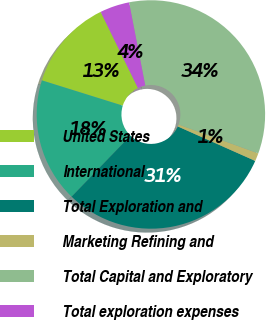<chart> <loc_0><loc_0><loc_500><loc_500><pie_chart><fcel>United States<fcel>International<fcel>Total Exploration and<fcel>Marketing Refining and<fcel>Total Capital and Exploratory<fcel>Total exploration expenses<nl><fcel>12.93%<fcel>17.61%<fcel>30.54%<fcel>1.13%<fcel>33.6%<fcel>4.18%<nl></chart> 